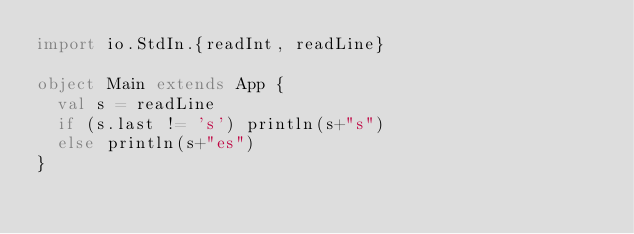<code> <loc_0><loc_0><loc_500><loc_500><_Scala_>import io.StdIn.{readInt, readLine}

object Main extends App {
  val s = readLine
  if (s.last != 's') println(s+"s")
  else println(s+"es")
}</code> 